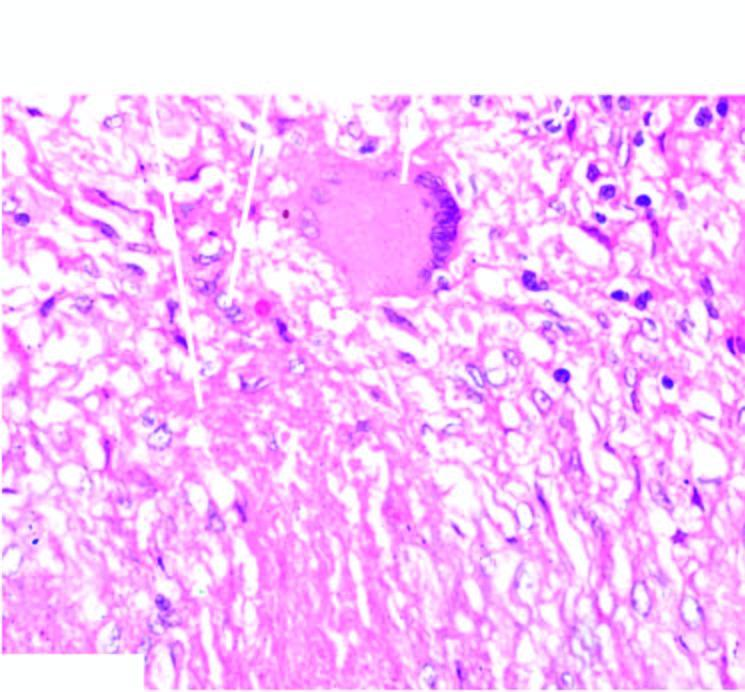what is surrounded by elongated epithelioid cells having characteristic slipper-shaped nuclei, with interspersed langhans ' giant cells?
Answer the question using a single word or phrase. Central caseation necrosis 